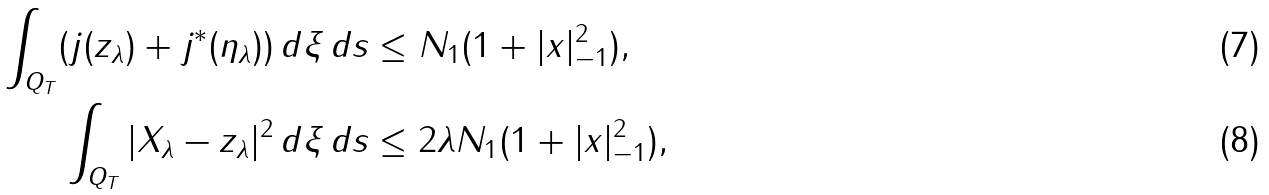Convert formula to latex. <formula><loc_0><loc_0><loc_500><loc_500>\int _ { Q _ { T } } ( j ( z _ { \lambda } ) + j ^ { * } ( \eta _ { \lambda } ) ) \, d \xi \, d s & \leq N _ { 1 } ( 1 + | x | _ { - 1 } ^ { 2 } ) , \\ \int _ { Q _ { T } } | X _ { \lambda } - z _ { \lambda } | ^ { 2 } \, d \xi \, d s & \leq 2 \lambda N _ { 1 } ( 1 + | x | _ { - 1 } ^ { 2 } ) ,</formula> 